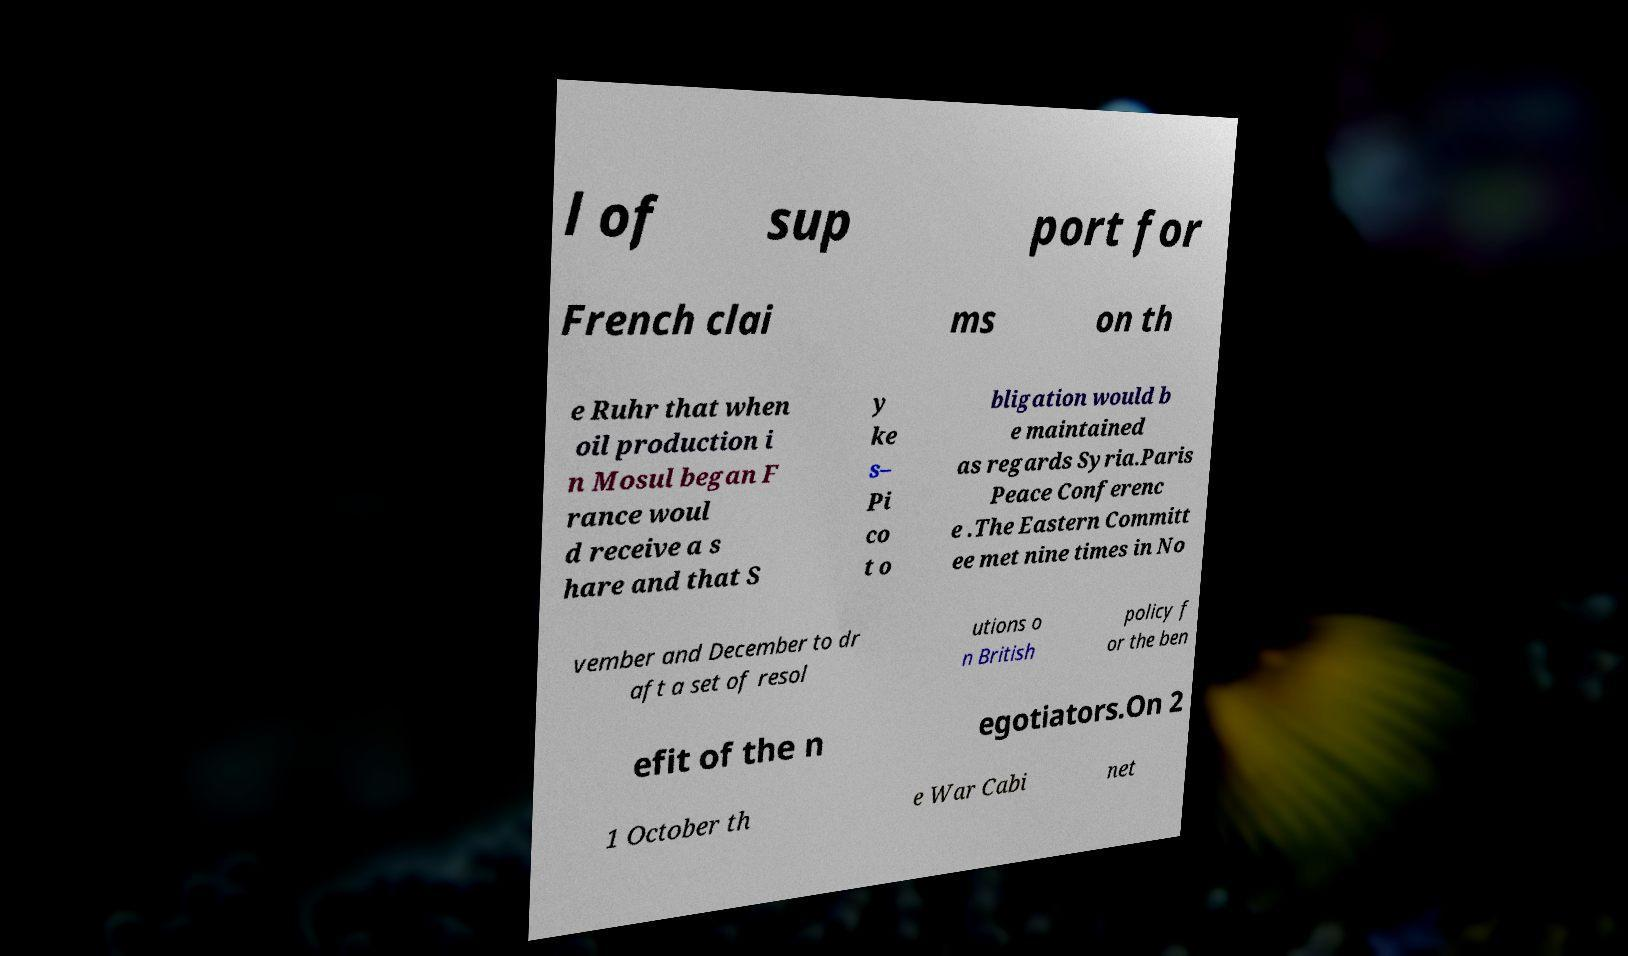What messages or text are displayed in this image? I need them in a readable, typed format. l of sup port for French clai ms on th e Ruhr that when oil production i n Mosul began F rance woul d receive a s hare and that S y ke s– Pi co t o bligation would b e maintained as regards Syria.Paris Peace Conferenc e .The Eastern Committ ee met nine times in No vember and December to dr aft a set of resol utions o n British policy f or the ben efit of the n egotiators.On 2 1 October th e War Cabi net 